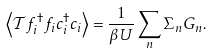<formula> <loc_0><loc_0><loc_500><loc_500>\left \langle \mathcal { T } f _ { i } ^ { \dagger } f _ { i } c _ { i } ^ { \dagger } c _ { i } \right \rangle = \frac { 1 } { \beta U } \sum _ { n } \Sigma _ { n } G _ { n } .</formula> 